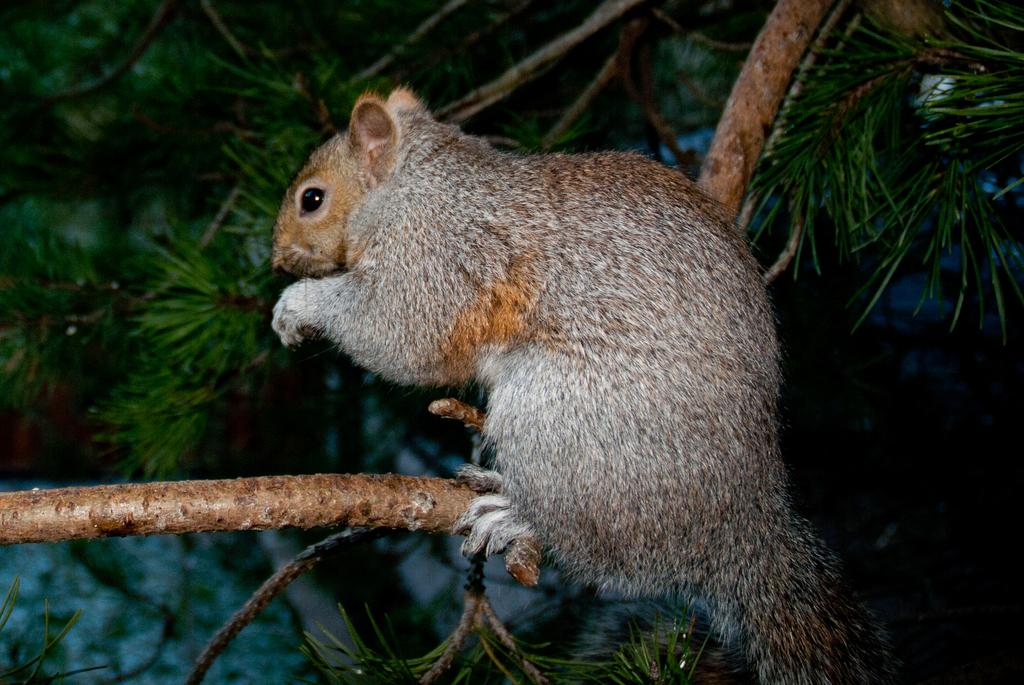What animal can be seen in the image? There is a squirrel in the squirrel in the image. Where is the squirrel located? The squirrel is in a tree. What type of representative is present in the image? There is no representative present in the image; it features a squirrel in a tree. What apparatus is used by the squirrel to start climbing the tree? Squirrels do not use any apparatus to start climbing trees; they have sharp claws that allow them to grip the bark and climb naturally. 